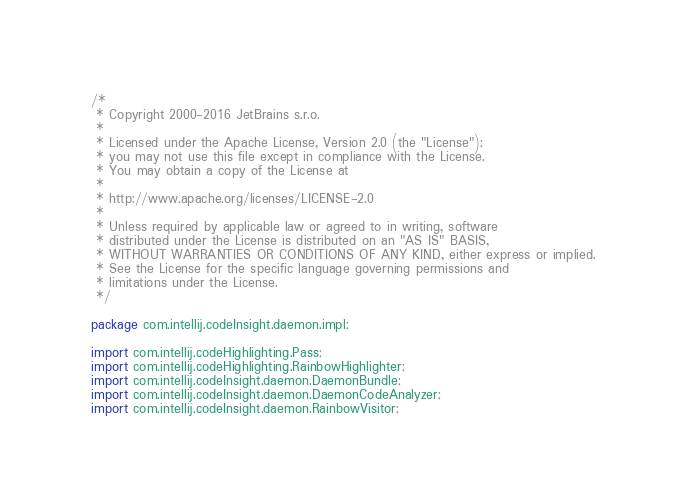<code> <loc_0><loc_0><loc_500><loc_500><_Java_>/*
 * Copyright 2000-2016 JetBrains s.r.o.
 *
 * Licensed under the Apache License, Version 2.0 (the "License");
 * you may not use this file except in compliance with the License.
 * You may obtain a copy of the License at
 *
 * http://www.apache.org/licenses/LICENSE-2.0
 *
 * Unless required by applicable law or agreed to in writing, software
 * distributed under the License is distributed on an "AS IS" BASIS,
 * WITHOUT WARRANTIES OR CONDITIONS OF ANY KIND, either express or implied.
 * See the License for the specific language governing permissions and
 * limitations under the License.
 */

package com.intellij.codeInsight.daemon.impl;

import com.intellij.codeHighlighting.Pass;
import com.intellij.codeHighlighting.RainbowHighlighter;
import com.intellij.codeInsight.daemon.DaemonBundle;
import com.intellij.codeInsight.daemon.DaemonCodeAnalyzer;
import com.intellij.codeInsight.daemon.RainbowVisitor;</code> 